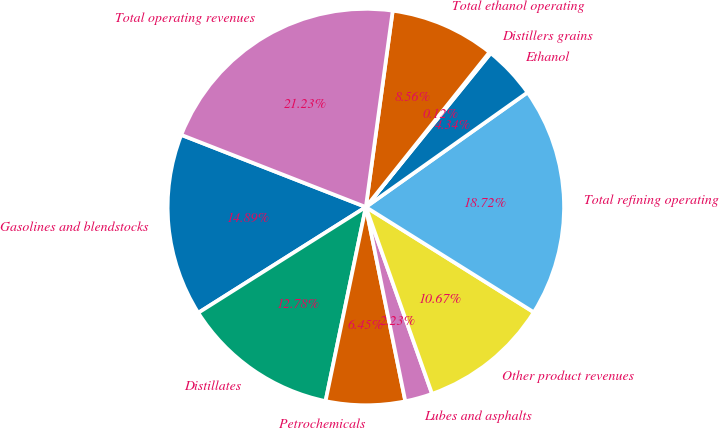Convert chart to OTSL. <chart><loc_0><loc_0><loc_500><loc_500><pie_chart><fcel>Gasolines and blendstocks<fcel>Distillates<fcel>Petrochemicals<fcel>Lubes and asphalts<fcel>Other product revenues<fcel>Total refining operating<fcel>Ethanol<fcel>Distillers grains<fcel>Total ethanol operating<fcel>Total operating revenues<nl><fcel>14.89%<fcel>12.78%<fcel>6.45%<fcel>2.23%<fcel>10.67%<fcel>18.72%<fcel>4.34%<fcel>0.12%<fcel>8.56%<fcel>21.23%<nl></chart> 